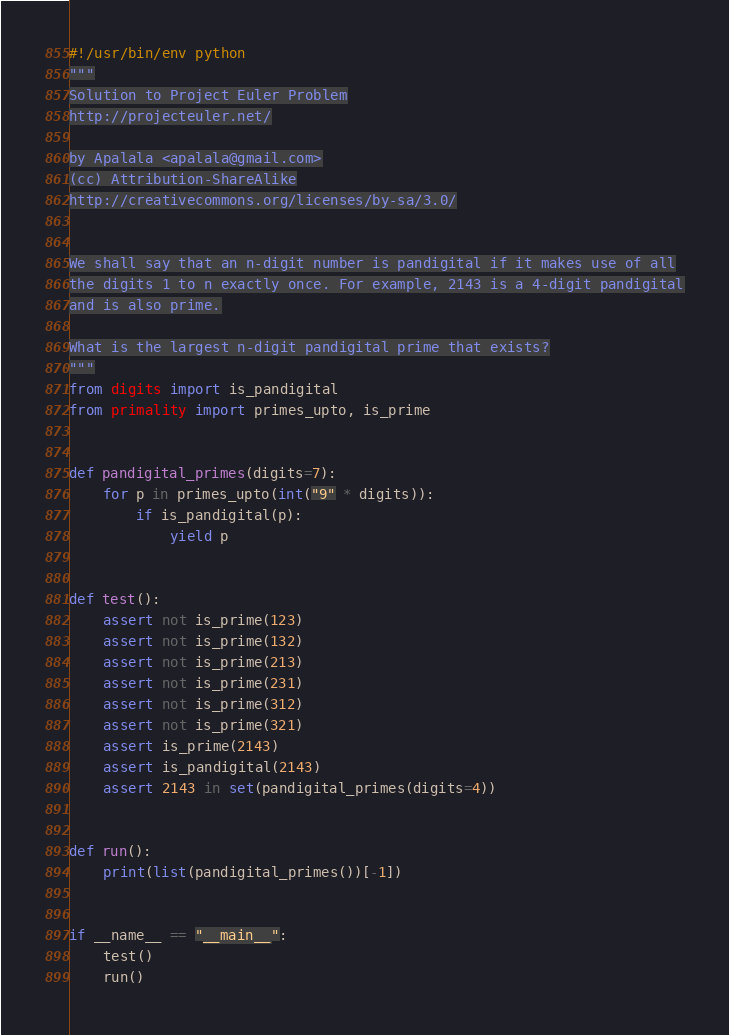Convert code to text. <code><loc_0><loc_0><loc_500><loc_500><_Python_>#!/usr/bin/env python
"""
Solution to Project Euler Problem
http://projecteuler.net/

by Apalala <apalala@gmail.com>
(cc) Attribution-ShareAlike
http://creativecommons.org/licenses/by-sa/3.0/


We shall say that an n-digit number is pandigital if it makes use of all
the digits 1 to n exactly once. For example, 2143 is a 4-digit pandigital
and is also prime.

What is the largest n-digit pandigital prime that exists?
"""
from digits import is_pandigital
from primality import primes_upto, is_prime


def pandigital_primes(digits=7):
    for p in primes_upto(int("9" * digits)):
        if is_pandigital(p):
            yield p


def test():
    assert not is_prime(123)
    assert not is_prime(132)
    assert not is_prime(213)
    assert not is_prime(231)
    assert not is_prime(312)
    assert not is_prime(321)
    assert is_prime(2143)
    assert is_pandigital(2143)
    assert 2143 in set(pandigital_primes(digits=4))


def run():
    print(list(pandigital_primes())[-1])


if __name__ == "__main__":
    test()
    run()
</code> 